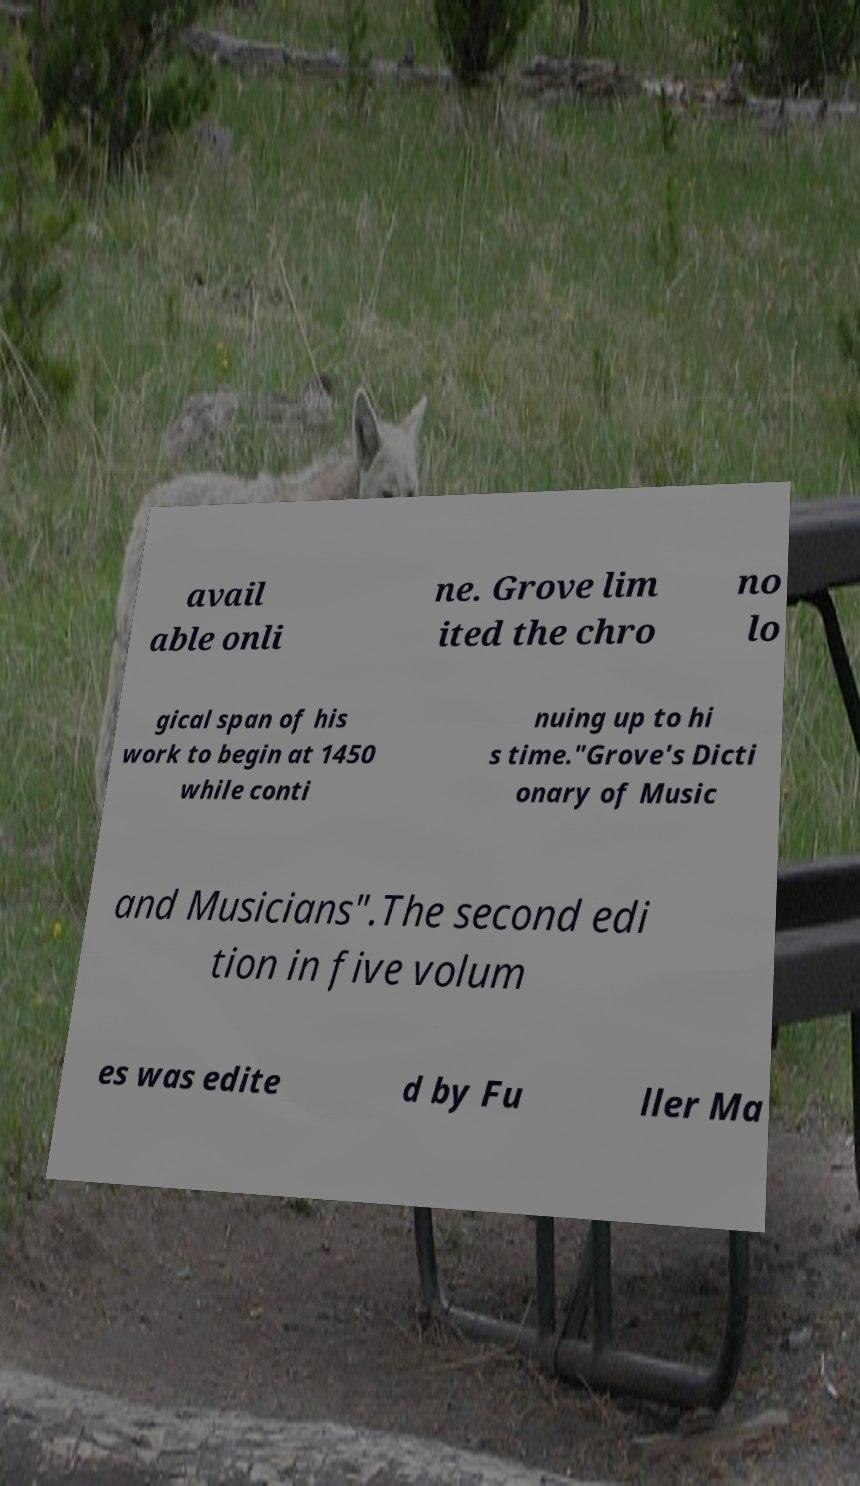Please read and relay the text visible in this image. What does it say? avail able onli ne. Grove lim ited the chro no lo gical span of his work to begin at 1450 while conti nuing up to hi s time."Grove's Dicti onary of Music and Musicians".The second edi tion in five volum es was edite d by Fu ller Ma 